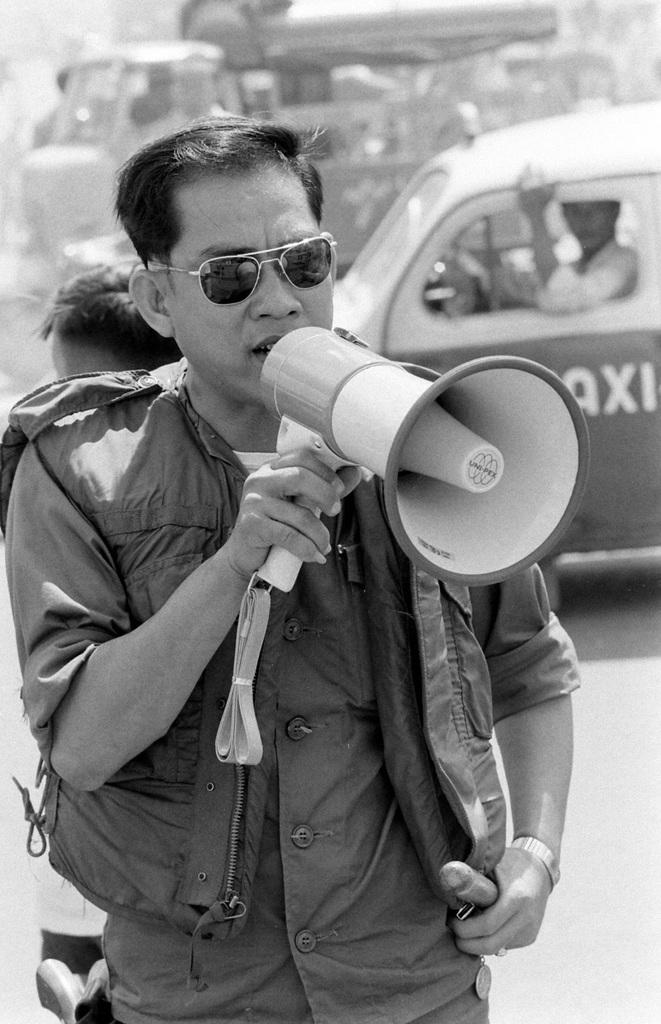Who is present in the image? There is a man in the image. What is the man wearing? The man is wearing a jacket. What is the man holding in the image? The man is holding a loudspeaker. What can be seen in the background of the image? There is a car in the background of the image. Where is the car located? The car is on the road. Who else is present in the image? There is another man inside the car. What type of pleasure does the man experience while holding the loudspeaker in the image? There is no indication of pleasure or any emotional state in the image; the man is simply holding a loudspeaker. 